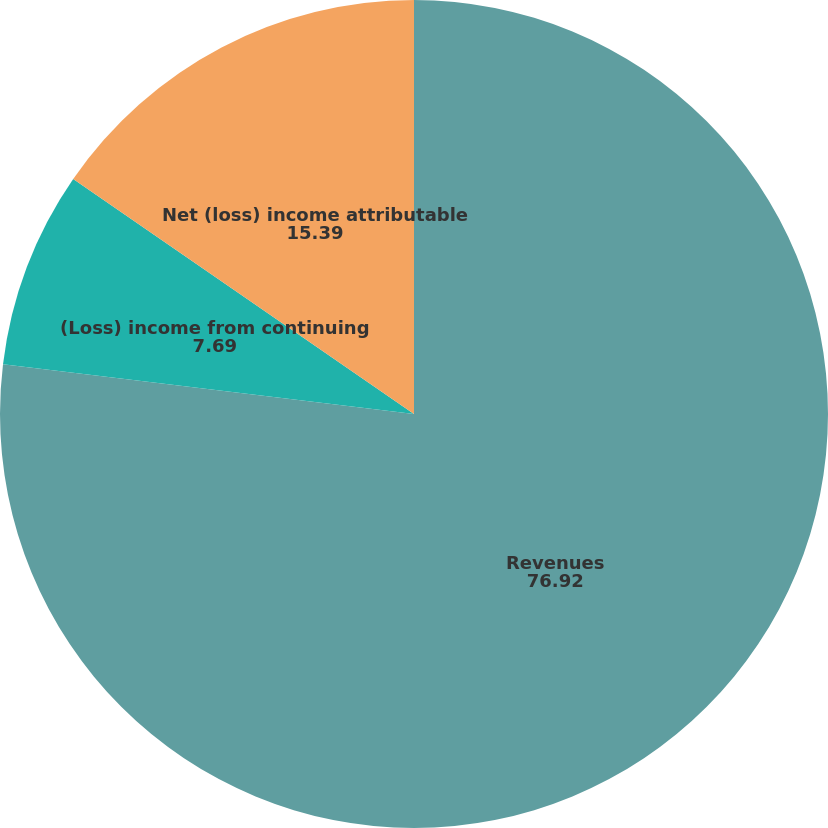<chart> <loc_0><loc_0><loc_500><loc_500><pie_chart><fcel>Revenues<fcel>(Loss) income from continuing<fcel>Net (loss) income attributable<fcel>Net (loss) income available to<nl><fcel>76.92%<fcel>7.69%<fcel>15.39%<fcel>0.0%<nl></chart> 